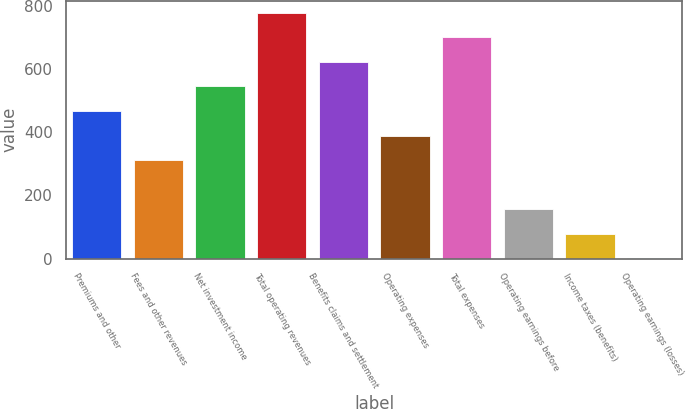Convert chart. <chart><loc_0><loc_0><loc_500><loc_500><bar_chart><fcel>Premiums and other<fcel>Fees and other revenues<fcel>Net investment income<fcel>Total operating revenues<fcel>Benefits claims and settlement<fcel>Operating expenses<fcel>Total expenses<fcel>Operating earnings before<fcel>Income taxes (benefits)<fcel>Operating earnings (losses)<nl><fcel>467.96<fcel>312.34<fcel>545.77<fcel>779.2<fcel>623.58<fcel>390.15<fcel>701.39<fcel>156.72<fcel>78.91<fcel>1.1<nl></chart> 